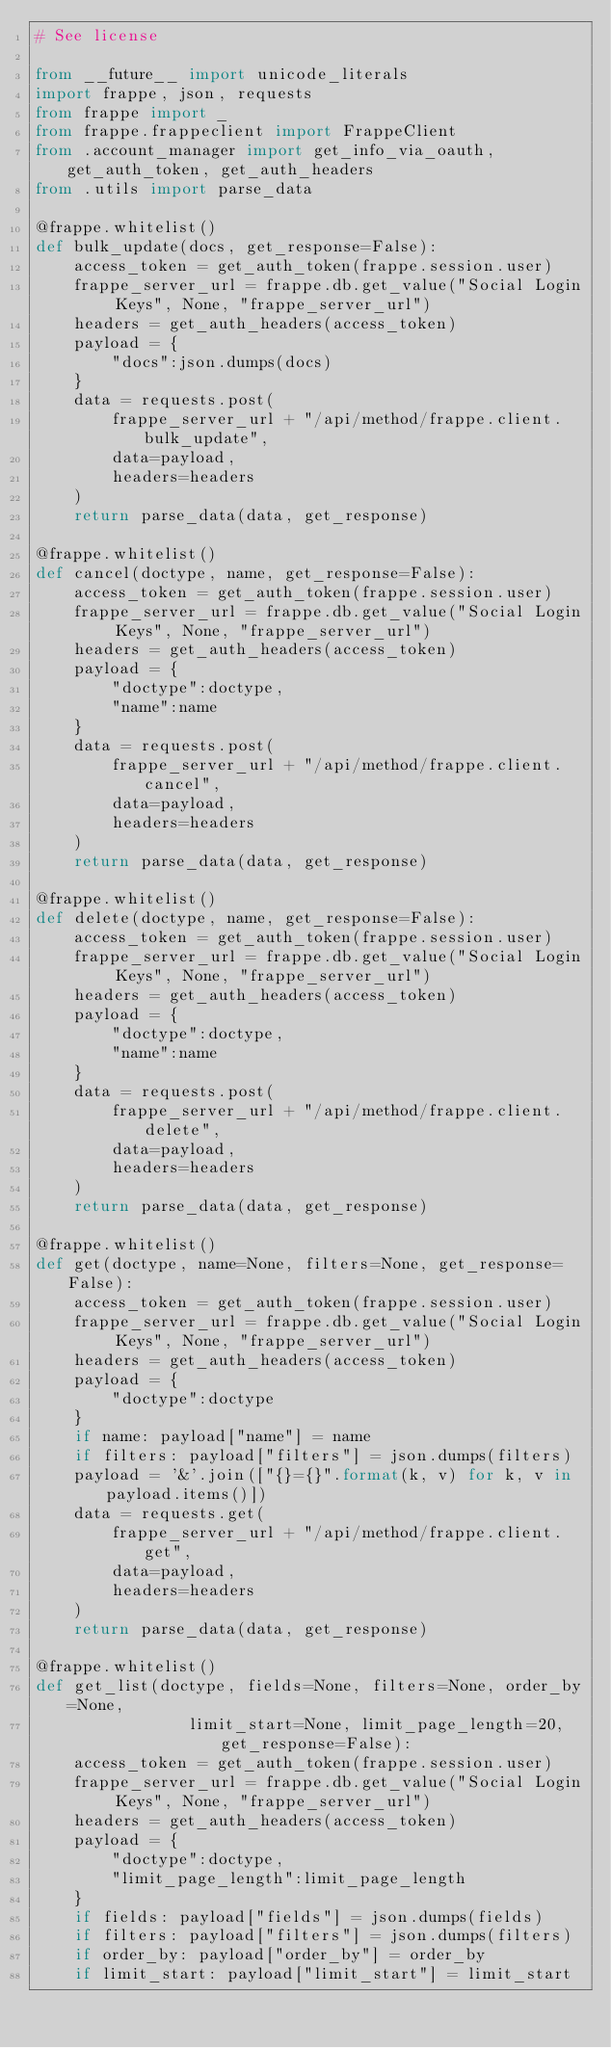Convert code to text. <code><loc_0><loc_0><loc_500><loc_500><_Python_># See license

from __future__ import unicode_literals
import frappe, json, requests
from frappe import _
from frappe.frappeclient import FrappeClient
from .account_manager import get_info_via_oauth, get_auth_token, get_auth_headers
from .utils import parse_data

@frappe.whitelist()
def bulk_update(docs, get_response=False):
	access_token = get_auth_token(frappe.session.user)
	frappe_server_url = frappe.db.get_value("Social Login Keys", None, "frappe_server_url")
	headers = get_auth_headers(access_token)
	payload = {
		"docs":json.dumps(docs)
	}
	data = requests.post(
		frappe_server_url + "/api/method/frappe.client.bulk_update",
		data=payload,
		headers=headers
	)
	return parse_data(data, get_response)

@frappe.whitelist()
def cancel(doctype, name, get_response=False):
	access_token = get_auth_token(frappe.session.user)
	frappe_server_url = frappe.db.get_value("Social Login Keys", None, "frappe_server_url")
	headers = get_auth_headers(access_token)
	payload = {
		"doctype":doctype,
		"name":name
	}
	data = requests.post(
		frappe_server_url + "/api/method/frappe.client.cancel",
		data=payload,
		headers=headers
	)
	return parse_data(data, get_response)

@frappe.whitelist()
def delete(doctype, name, get_response=False):
	access_token = get_auth_token(frappe.session.user)
	frappe_server_url = frappe.db.get_value("Social Login Keys", None, "frappe_server_url")
	headers = get_auth_headers(access_token)
	payload = {
		"doctype":doctype,
		"name":name
	}
	data = requests.post(
		frappe_server_url + "/api/method/frappe.client.delete",
		data=payload,
		headers=headers
	)
	return parse_data(data, get_response)

@frappe.whitelist()
def get(doctype, name=None, filters=None, get_response=False):
	access_token = get_auth_token(frappe.session.user)
	frappe_server_url = frappe.db.get_value("Social Login Keys", None, "frappe_server_url")
	headers = get_auth_headers(access_token)
	payload = {
		"doctype":doctype
	}
	if name: payload["name"] = name
	if filters: payload["filters"] = json.dumps(filters)
	payload = '&'.join(["{}={}".format(k, v) for k, v in payload.items()])
	data = requests.get(
		frappe_server_url + "/api/method/frappe.client.get",
		data=payload,
		headers=headers
	)
	return parse_data(data, get_response)

@frappe.whitelist()
def get_list(doctype, fields=None, filters=None, order_by=None,
				limit_start=None, limit_page_length=20, get_response=False):
	access_token = get_auth_token(frappe.session.user)
	frappe_server_url = frappe.db.get_value("Social Login Keys", None, "frappe_server_url")
	headers = get_auth_headers(access_token)
	payload = {
		"doctype":doctype,
		"limit_page_length":limit_page_length
	}
	if fields: payload["fields"] = json.dumps(fields)
	if filters: payload["filters"] = json.dumps(filters)
	if order_by: payload["order_by"] = order_by
	if limit_start: payload["limit_start"] = limit_start</code> 